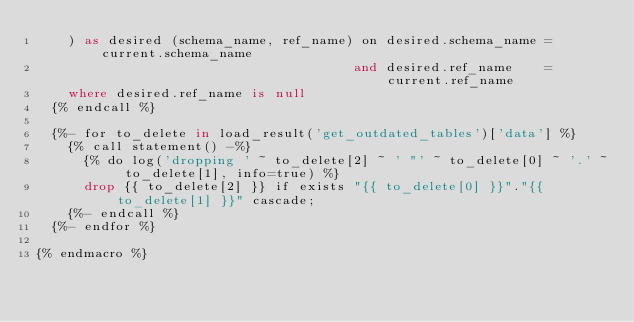<code> <loc_0><loc_0><loc_500><loc_500><_SQL_>    ) as desired (schema_name, ref_name) on desired.schema_name = current.schema_name
                                        and desired.ref_name    = current.ref_name
    where desired.ref_name is null
  {% endcall %}

  {%- for to_delete in load_result('get_outdated_tables')['data'] %} 
    {% call statement() -%}
      {% do log('dropping ' ~ to_delete[2] ~ ' "' ~ to_delete[0] ~ '.' ~ to_delete[1], info=true) %}
      drop {{ to_delete[2] }} if exists "{{ to_delete[0] }}"."{{ to_delete[1] }}" cascade;
    {%- endcall %}
  {%- endfor %}

{% endmacro %}</code> 